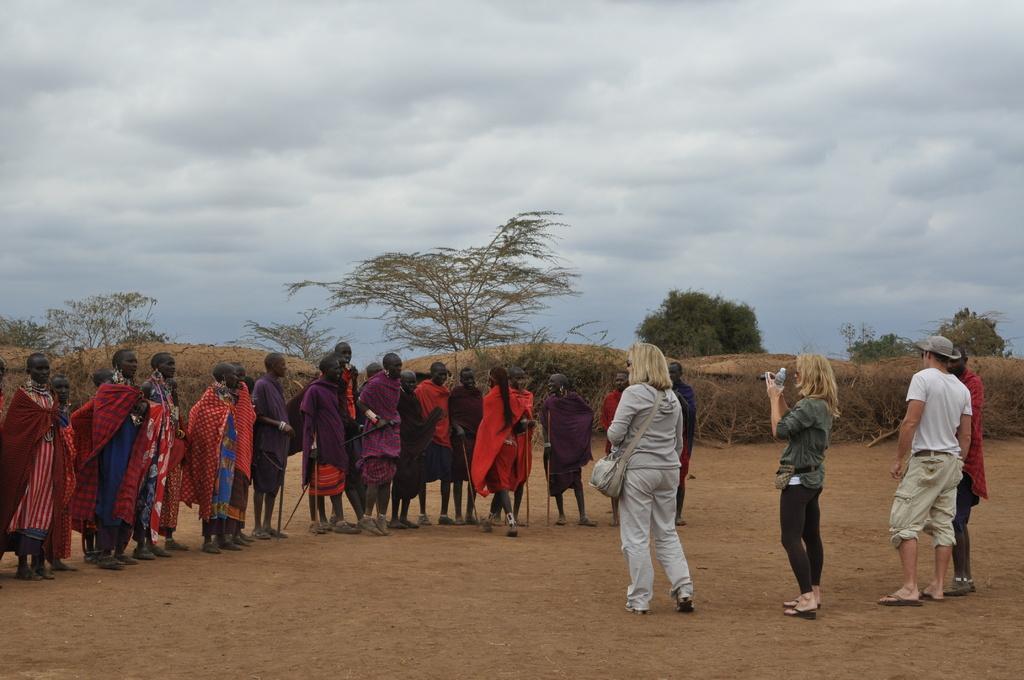How would you summarize this image in a sentence or two? In this picture there is a woman who is wearing t-shirt, trouser and shoe. Beside her we can see another woman who is holding a camera. Here we can see a man who is wearing white t-shirt, trouser, cap, goggle and sleeper. On the left we can see group of persons standing on the ground. In the back we can see plants and trees. On the top we can see sky and clouds. 